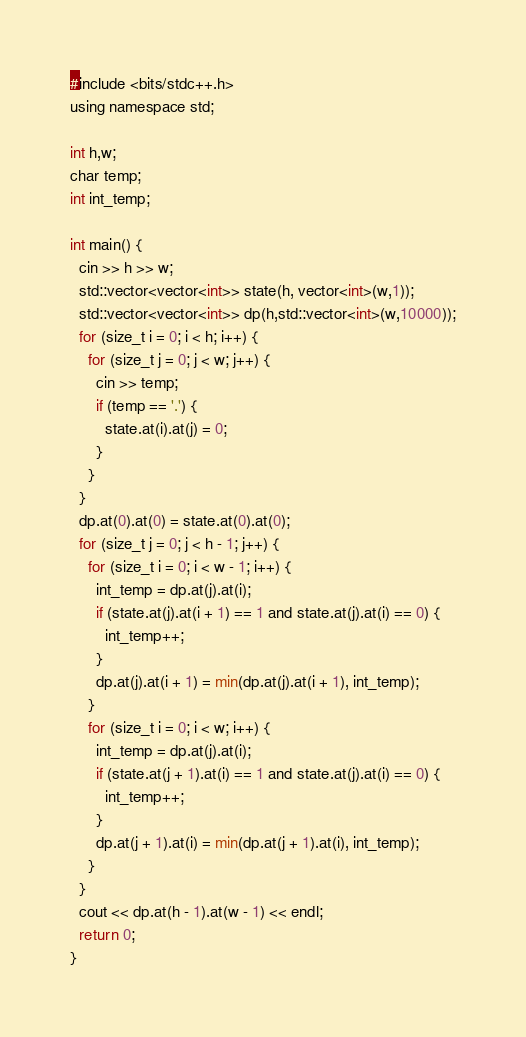<code> <loc_0><loc_0><loc_500><loc_500><_Go_>#include <bits/stdc++.h>
using namespace std;

int h,w;
char temp;
int int_temp;

int main() {
  cin >> h >> w;
  std::vector<vector<int>> state(h, vector<int>(w,1));
  std::vector<vector<int>> dp(h,std::vector<int>(w,10000));
  for (size_t i = 0; i < h; i++) {
    for (size_t j = 0; j < w; j++) {
      cin >> temp;
      if (temp == '.') {
        state.at(i).at(j) = 0;
      }
    }
  }
  dp.at(0).at(0) = state.at(0).at(0);
  for (size_t j = 0; j < h - 1; j++) {
    for (size_t i = 0; i < w - 1; i++) {
      int_temp = dp.at(j).at(i);
      if (state.at(j).at(i + 1) == 1 and state.at(j).at(i) == 0) {
        int_temp++;
      }
      dp.at(j).at(i + 1) = min(dp.at(j).at(i + 1), int_temp);
    }
    for (size_t i = 0; i < w; i++) {
      int_temp = dp.at(j).at(i);
      if (state.at(j + 1).at(i) == 1 and state.at(j).at(i) == 0) {
        int_temp++;
      }
      dp.at(j + 1).at(i) = min(dp.at(j + 1).at(i), int_temp);
    }
  }
  cout << dp.at(h - 1).at(w - 1) << endl;
  return 0;
}
</code> 